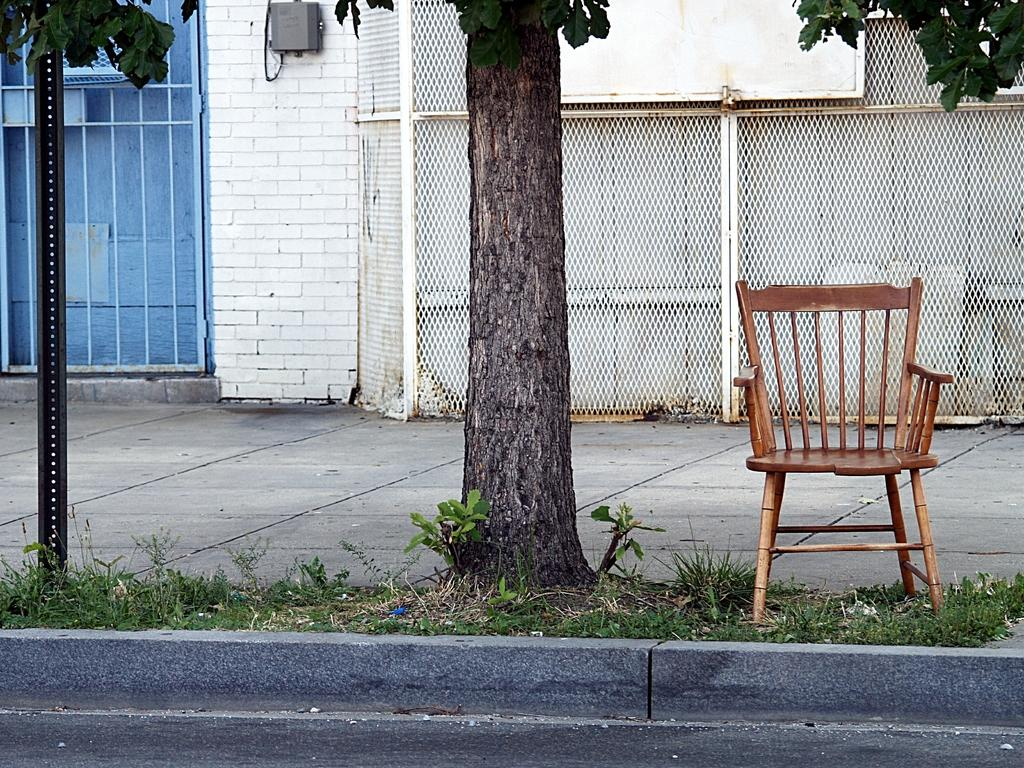What type of furniture is on the land in the image? There is a chair on the land in the image. What is located near the chair? There are plants near the chair. What type of vegetation can be seen in the image? There is a tree in the image. What is on the left side of the image? There is a pole on the left side of the image. What is visible in the background of the image? There is a wall in the background of the image. What is the wall's feature? The wall has a fence. What can be seen at the bottom of the image? There is a road visible at the bottom of the image. How much credit is available for the person wearing the mask in the image? There is no person wearing a mask in the image, and therefore no credit information can be provided. What type of payment is required for the services provided by the pole in the image? There is no payment required for the pole in the image, as it is a stationary object. 